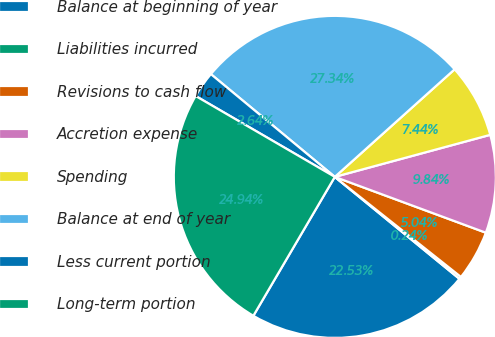<chart> <loc_0><loc_0><loc_500><loc_500><pie_chart><fcel>Balance at beginning of year<fcel>Liabilities incurred<fcel>Revisions to cash flow<fcel>Accretion expense<fcel>Spending<fcel>Balance at end of year<fcel>Less current portion<fcel>Long-term portion<nl><fcel>22.53%<fcel>0.24%<fcel>5.04%<fcel>9.84%<fcel>7.44%<fcel>27.34%<fcel>2.64%<fcel>24.94%<nl></chart> 